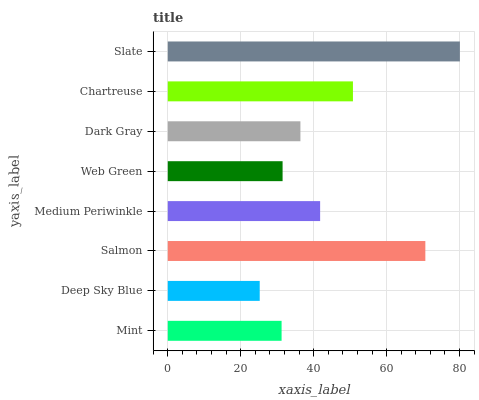Is Deep Sky Blue the minimum?
Answer yes or no. Yes. Is Slate the maximum?
Answer yes or no. Yes. Is Salmon the minimum?
Answer yes or no. No. Is Salmon the maximum?
Answer yes or no. No. Is Salmon greater than Deep Sky Blue?
Answer yes or no. Yes. Is Deep Sky Blue less than Salmon?
Answer yes or no. Yes. Is Deep Sky Blue greater than Salmon?
Answer yes or no. No. Is Salmon less than Deep Sky Blue?
Answer yes or no. No. Is Medium Periwinkle the high median?
Answer yes or no. Yes. Is Dark Gray the low median?
Answer yes or no. Yes. Is Mint the high median?
Answer yes or no. No. Is Deep Sky Blue the low median?
Answer yes or no. No. 